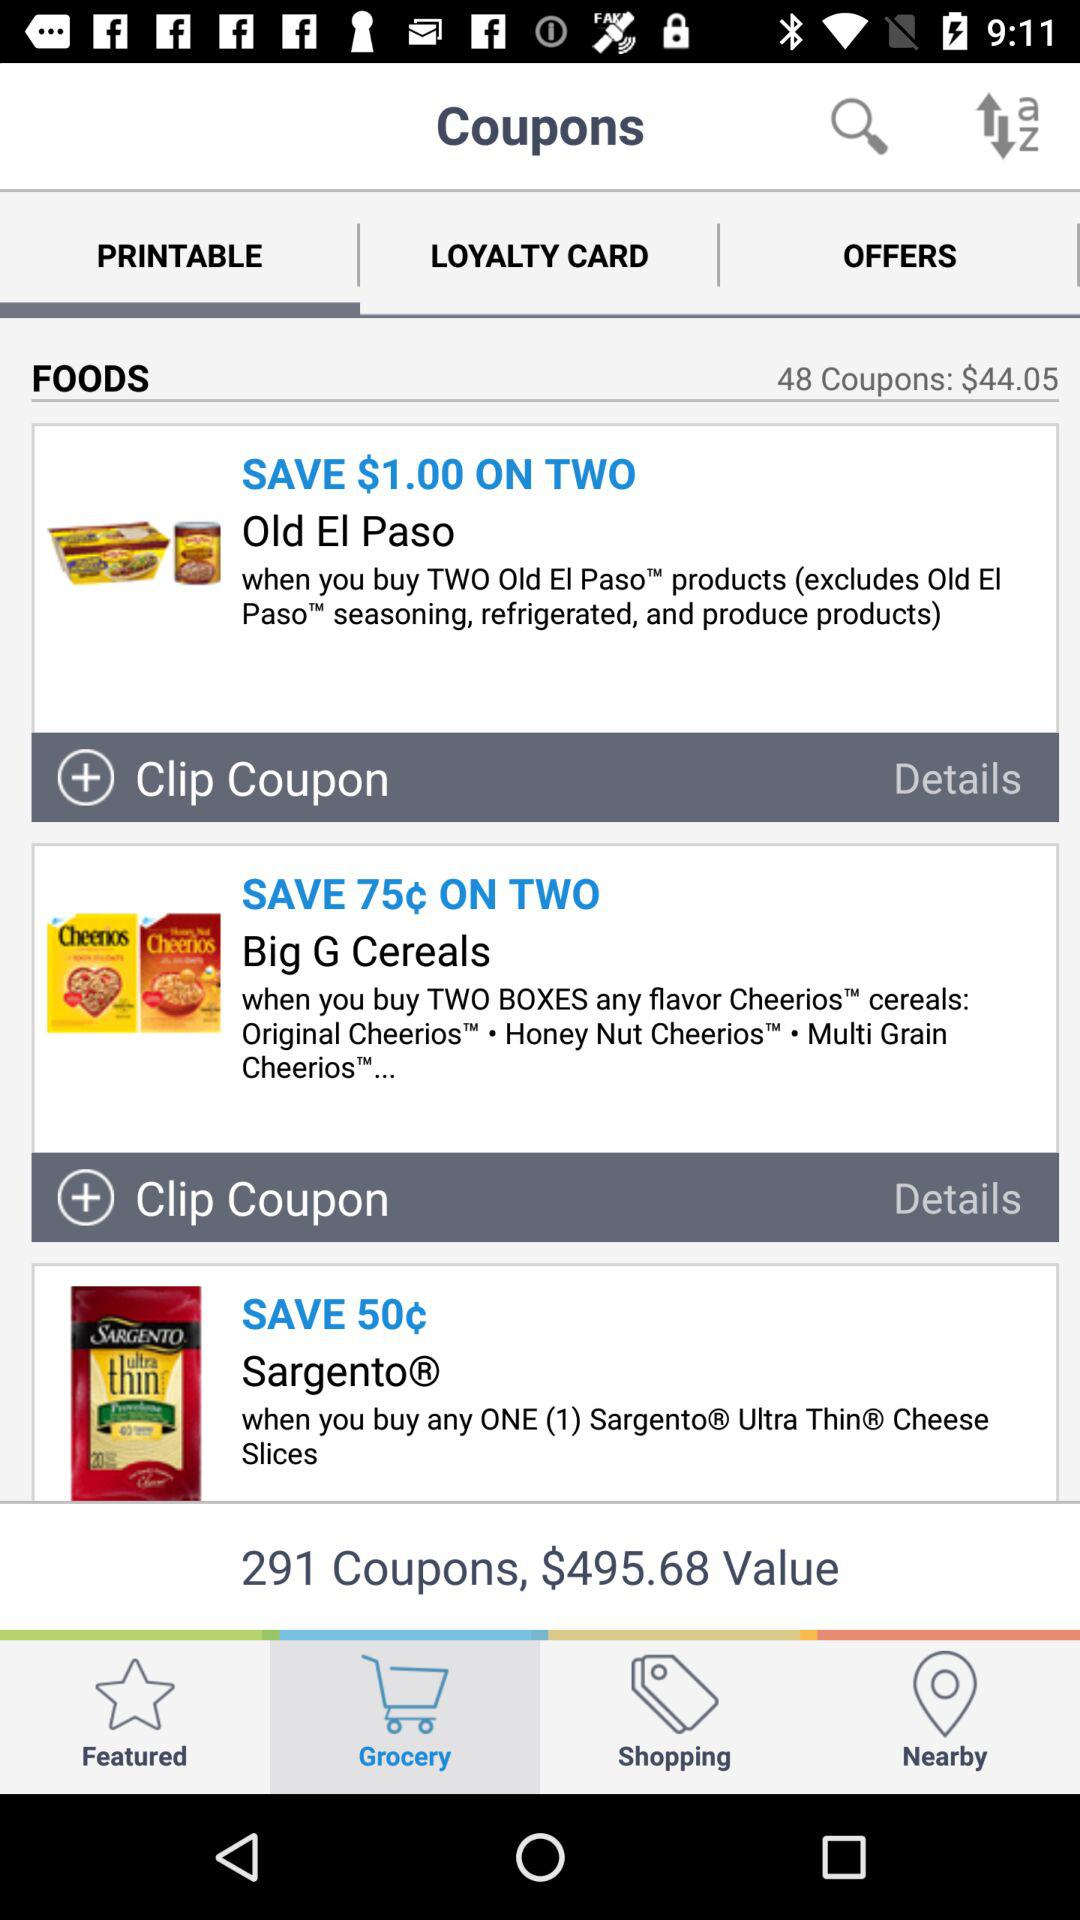What tab is selected? The selected tabs are "Grocery" and "PRINTABLE". 